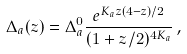<formula> <loc_0><loc_0><loc_500><loc_500>\Delta _ { a } ( z ) = \Delta _ { a } ^ { 0 } \frac { e ^ { K _ { a } z ( 4 - z ) / 2 } } { ( 1 + z / 2 ) ^ { 4 K _ { a } } } \, ,</formula> 